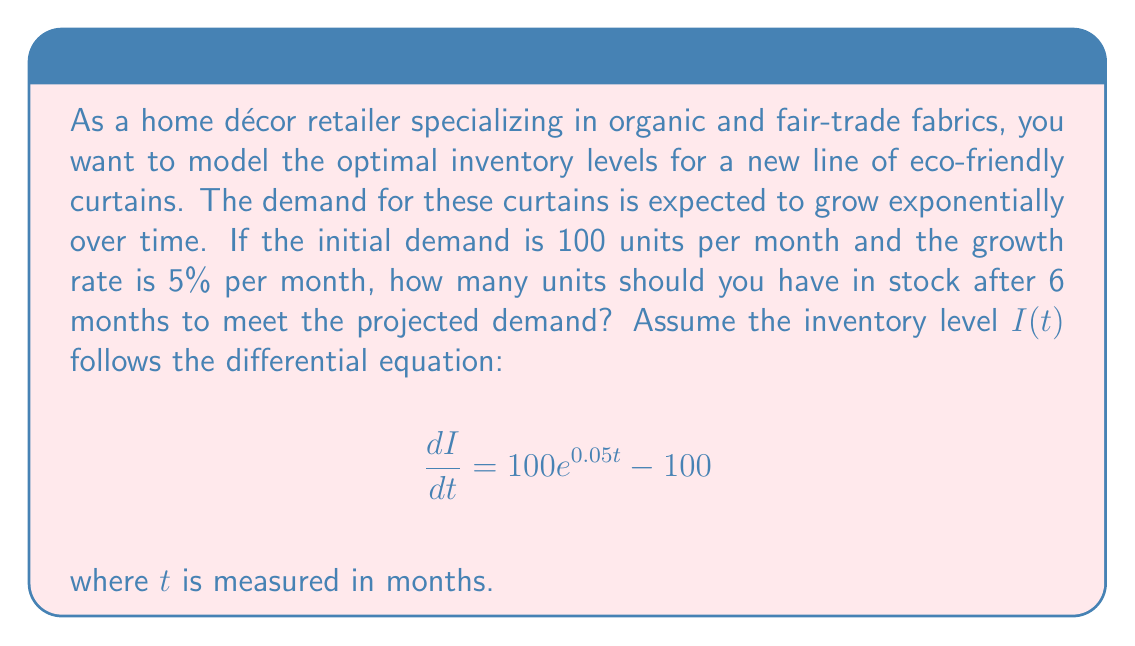Can you solve this math problem? To solve this problem, we need to integrate the given differential equation:

1) The general form of the equation is:
   $$\frac{dI}{dt} = 100e^{0.05t} - 100$$

2) Integrate both sides with respect to $t$:
   $$\int \frac{dI}{dt} dt = \int (100e^{0.05t} - 100) dt$$

3) The left side simplifies to $I$. For the right side:
   $$I = 100 \int e^{0.05t} dt - 100t + C$$

4) Integrate the exponential term:
   $$I = 100 \cdot \frac{1}{0.05} e^{0.05t} - 100t + C$$
   $$I = 2000e^{0.05t} - 100t + C$$

5) To find $C$, use the initial condition. At $t=0$, $I(0) = 0$:
   $$0 = 2000e^{0.05 \cdot 0} - 100 \cdot 0 + C$$
   $$0 = 2000 + C$$
   $$C = -2000$$

6) The particular solution is:
   $$I(t) = 2000e^{0.05t} - 100t - 2000$$

7) To find the inventory level after 6 months, substitute $t=6$:
   $$I(6) = 2000e^{0.05 \cdot 6} - 100 \cdot 6 - 2000$$
   $$I(6) = 2000e^{0.3} - 600 - 2000$$
   $$I(6) = 2000 \cdot 1.34986 - 2600$$
   $$I(6) = 2699.72 - 2600$$
   $$I(6) \approx 99.72$$

8) Round up to the nearest whole unit for practical inventory management.
Answer: The optimal inventory level after 6 months should be 100 units. 